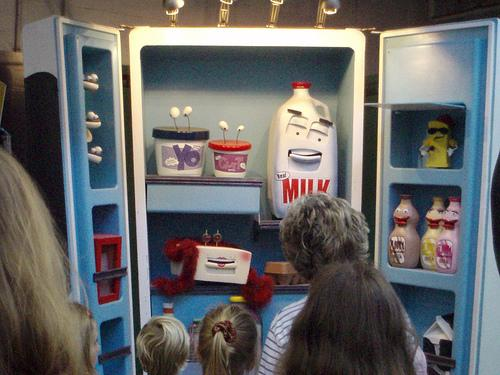Identify how many people are present in the image and describe their actions. There are two children in the image, and they are looking inside the fridge. Find and count the number of different containers with faces in the image. There are 4 containers with faces: a milk carton, a bottle of mustard, a white yogurt container, and a white and purple container. What kind of refrigeration appliance is in the image, and what is unique about its appearance? The image has a blue refrigerator that is fake and has been described as having lights on top of it, giving a lit-up appearance. Describe the appearance of the girl with blonde hair in the image. The girl with blonde hair is wearing a ponytail tied with a red hair scrunchie and has a brown ponytail holder in her hair. Describe the interaction between any two objects within the image. The milk carton with a cartoony face is seemingly interacting with the mustard bottle as both have faces and are placed close to each other inside the refrigerator. What is the sentiment of the image based on the objects present? The image has a playful and fun sentiment, with various containers having faces, and some objects like the mustard wearing sunglasses. Provide a caption for the image, capturing the main theme or idea. Two curious children explore a blue refrigerator filled with playful containers featuring cartoony faces and amusing details. Could you please find the green cat sitting on top of the refrigerator and pay close attention to its long, fluffy tail? No, it's not mentioned in the image. Can you point out the hidden treasure chest, filled with gold and precious gems, tucked away in the far corner of the refrigerator? A treasure chest is not mentioned in the information provided. This instruction uses an interrogative sentence and an adventurous language style to make the user believe there might be a hidden object they need to find. Locate the peculiar alien being hovering above the fridge, focusing on its tentacle-like arms and bright glowing eyes. There is no alien mentioned in the image. This instruction uses a more formal and descriptive language style to create an image of a non-existent object, misdirecting the user to search for something that isn't there. 